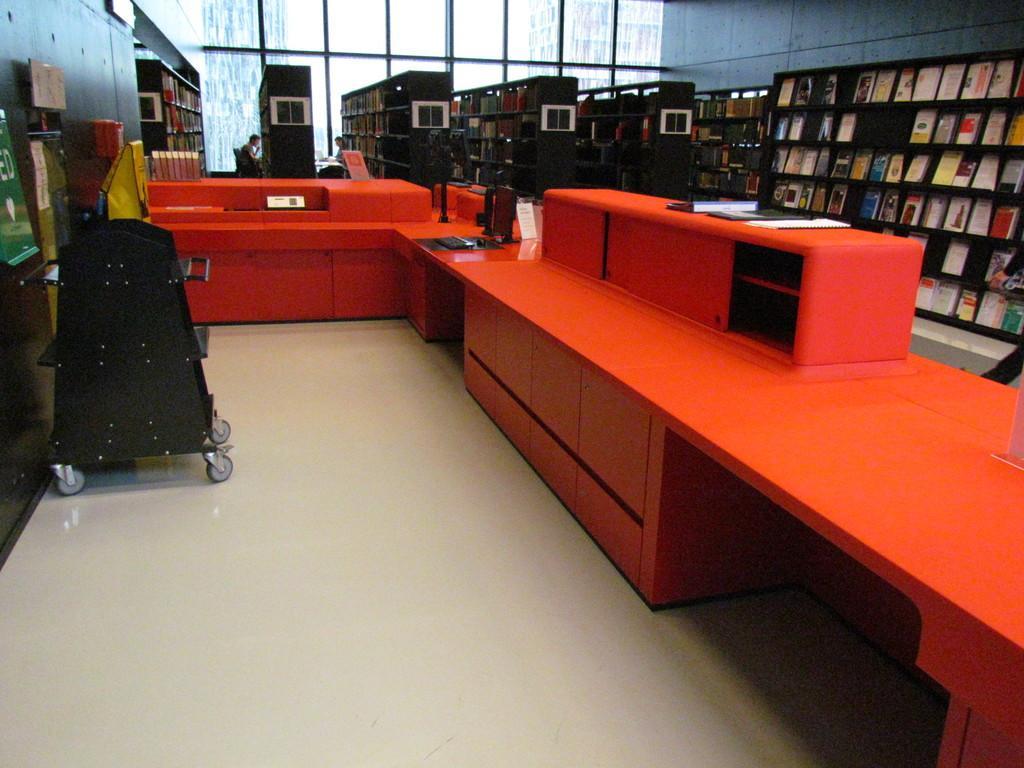Describe this image in one or two sentences. In this image there are tables. On top of it there is a computer and a few other objects. On the left side of the image there are some objects. There are books on the racks. In the background of the image there are glass windows through which we can see the buildings. At the bottom of the image there is a floor. 